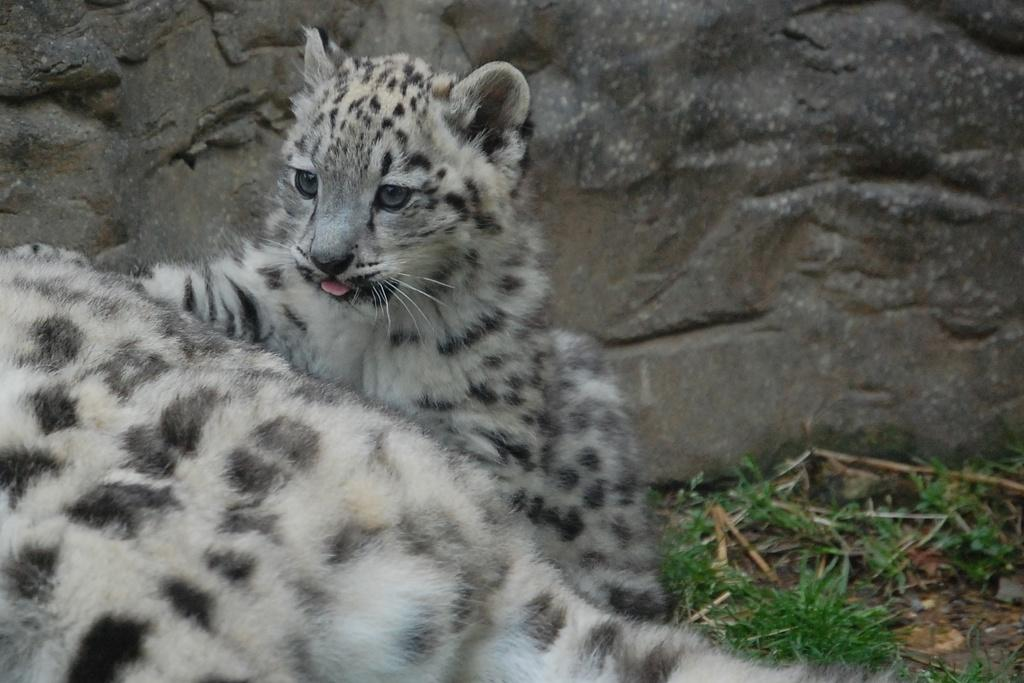What type of animal is in the image? There is a cheetah in the image. Can you describe the cheetah's offspring in the image? There is a cheetah cub in the image. What type of vegetation is visible in the image? There is grass visible in the image. What type of geological feature can be seen in the background of the image? There is a rock in the background of the image. Where might this image have been taken? The image might have been taken in a zoo. What type of education does the cheetah receive in the image? The image does not depict any form of education for the cheetah, as it is a photograph of an animal. 